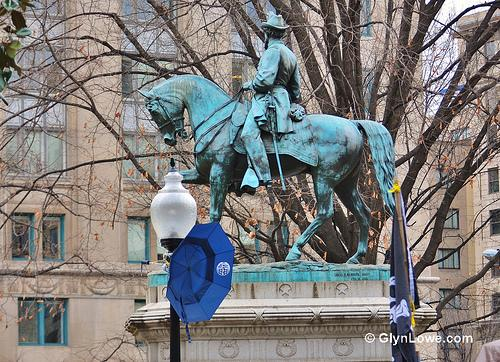Describe the most eye-catching aspects of the image. The striking equestrian statue of a man, the vibrant blue umbrella on the lamppost, and the imposing brown building in the backdrop. Create a short narrative about the picture, including major details. In the picture, a statue of a man on a horse stands amidst a leafless tree, an open blue umbrella on a lamppost, and a tall building forming a contrasting background. List the main subjects in the image, including color information. Verdigris man on horse statue, blue open umbrella on lamppost, bare tree, blue and white flag, and brown building. Provide a concise overview of what the picture captures. The picture captures a man-on-horse statue, an umbrella-attached lamppost, a leafless tree, a flag, and a large building as the background. Provide a succinct summary of the main components in the picture. Man on a horse statue, leafless tree, blue umbrella on lamppost, blue and white flag, and a large brown building. Identify the primary scene in the image along with any noteworthy details. A verdigris equestrian statue of a man, with an open blue umbrella attached to a black street light pole, a bare tree, and a large building in the background. Enumerate the dominant objects in the image and their respective colors. Man on horse statue (verdigris), blue umbrella, brown building, tree with bare branches, blue and white flag, and black street light pole. State the primary focus of the image and its features. A statue of a man on a horse with a sword and hat, surrounded by a tree with no leaves, a blue umbrella attached to a lamppost, and a brown building in the background. Mention the primary elements in the image and describe their appearance. An equestrian statue of a man wearing a hat and holding a sword, a large tree with no leaves, a blue and white flag, and a blue umbrella attached to a lamppost. Briefly mention the key elements in the photograph. The image features a horse and rider statue, a leafless tree, a blue umbrella on a lamp post, a flag, and a large building. 